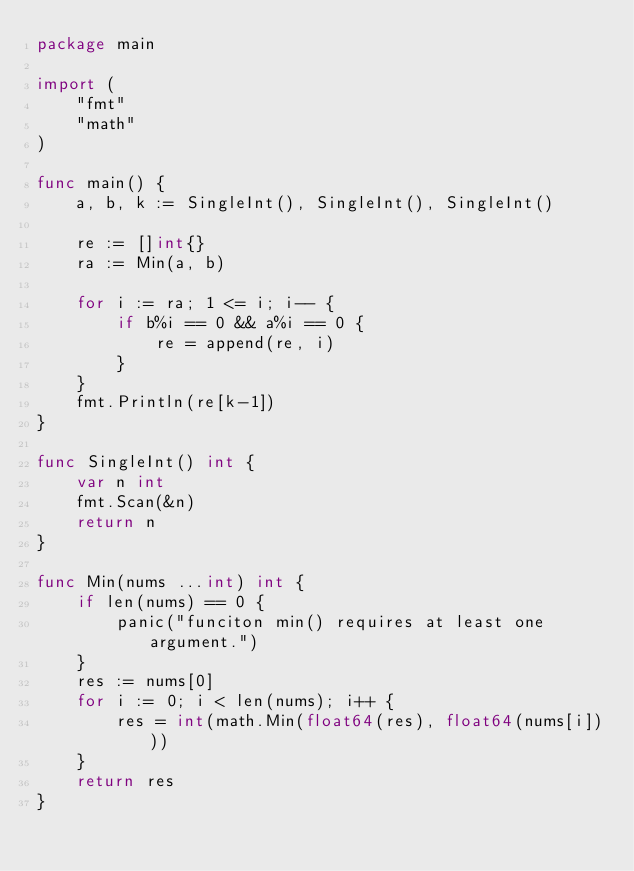<code> <loc_0><loc_0><loc_500><loc_500><_Go_>package main

import (
	"fmt"
	"math"
)

func main() {
	a, b, k := SingleInt(), SingleInt(), SingleInt()

	re := []int{}
	ra := Min(a, b)

	for i := ra; 1 <= i; i-- {
		if b%i == 0 && a%i == 0 {
			re = append(re, i)
		}
	}
	fmt.Println(re[k-1])
}

func SingleInt() int {
	var n int
	fmt.Scan(&n)
	return n
}

func Min(nums ...int) int {
	if len(nums) == 0 {
		panic("funciton min() requires at least one argument.")
	}
	res := nums[0]
	for i := 0; i < len(nums); i++ {
		res = int(math.Min(float64(res), float64(nums[i])))
	}
	return res
}
</code> 